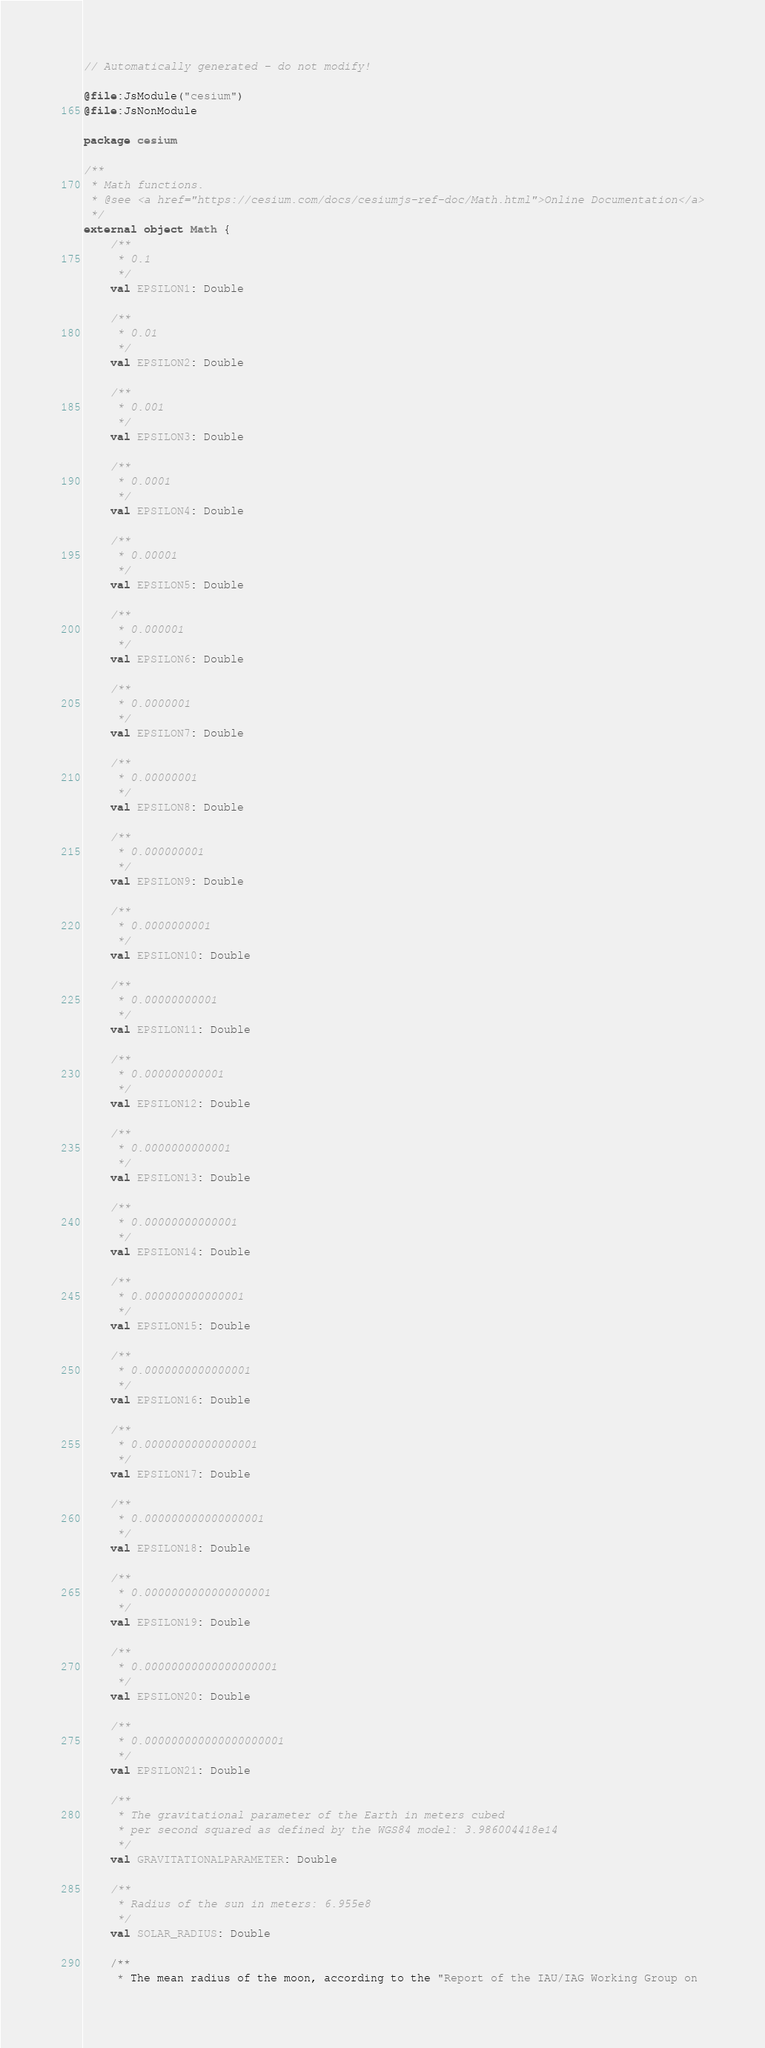<code> <loc_0><loc_0><loc_500><loc_500><_Kotlin_>// Automatically generated - do not modify!

@file:JsModule("cesium")
@file:JsNonModule

package cesium

/**
 * Math functions.
 * @see <a href="https://cesium.com/docs/cesiumjs-ref-doc/Math.html">Online Documentation</a>
 */
external object Math {
    /**
     * 0.1
     */
    val EPSILON1: Double

    /**
     * 0.01
     */
    val EPSILON2: Double

    /**
     * 0.001
     */
    val EPSILON3: Double

    /**
     * 0.0001
     */
    val EPSILON4: Double

    /**
     * 0.00001
     */
    val EPSILON5: Double

    /**
     * 0.000001
     */
    val EPSILON6: Double

    /**
     * 0.0000001
     */
    val EPSILON7: Double

    /**
     * 0.00000001
     */
    val EPSILON8: Double

    /**
     * 0.000000001
     */
    val EPSILON9: Double

    /**
     * 0.0000000001
     */
    val EPSILON10: Double

    /**
     * 0.00000000001
     */
    val EPSILON11: Double

    /**
     * 0.000000000001
     */
    val EPSILON12: Double

    /**
     * 0.0000000000001
     */
    val EPSILON13: Double

    /**
     * 0.00000000000001
     */
    val EPSILON14: Double

    /**
     * 0.000000000000001
     */
    val EPSILON15: Double

    /**
     * 0.0000000000000001
     */
    val EPSILON16: Double

    /**
     * 0.00000000000000001
     */
    val EPSILON17: Double

    /**
     * 0.000000000000000001
     */
    val EPSILON18: Double

    /**
     * 0.0000000000000000001
     */
    val EPSILON19: Double

    /**
     * 0.00000000000000000001
     */
    val EPSILON20: Double

    /**
     * 0.000000000000000000001
     */
    val EPSILON21: Double

    /**
     * The gravitational parameter of the Earth in meters cubed
     * per second squared as defined by the WGS84 model: 3.986004418e14
     */
    val GRAVITATIONALPARAMETER: Double

    /**
     * Radius of the sun in meters: 6.955e8
     */
    val SOLAR_RADIUS: Double

    /**
     * The mean radius of the moon, according to the "Report of the IAU/IAG Working Group on</code> 